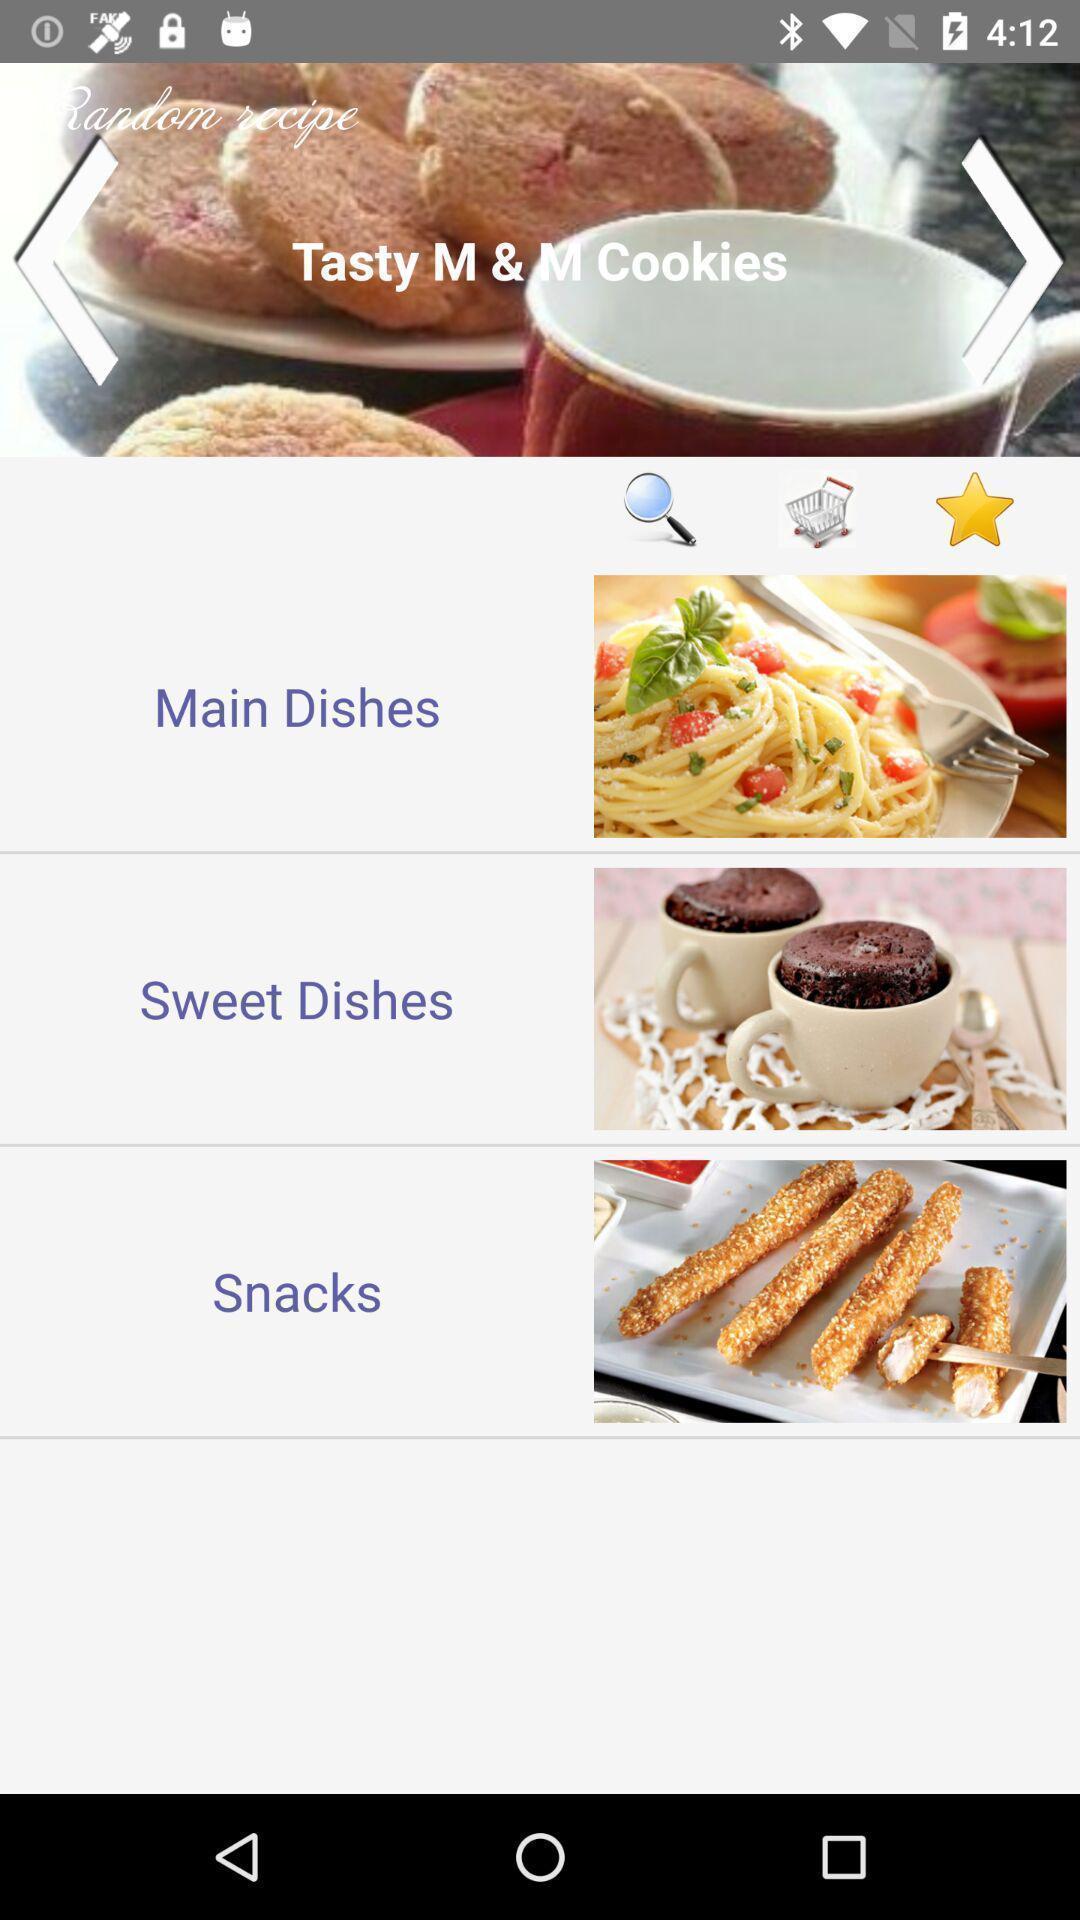Give me a summary of this screen capture. Page showing main dishes sweet dishes and snacks. 